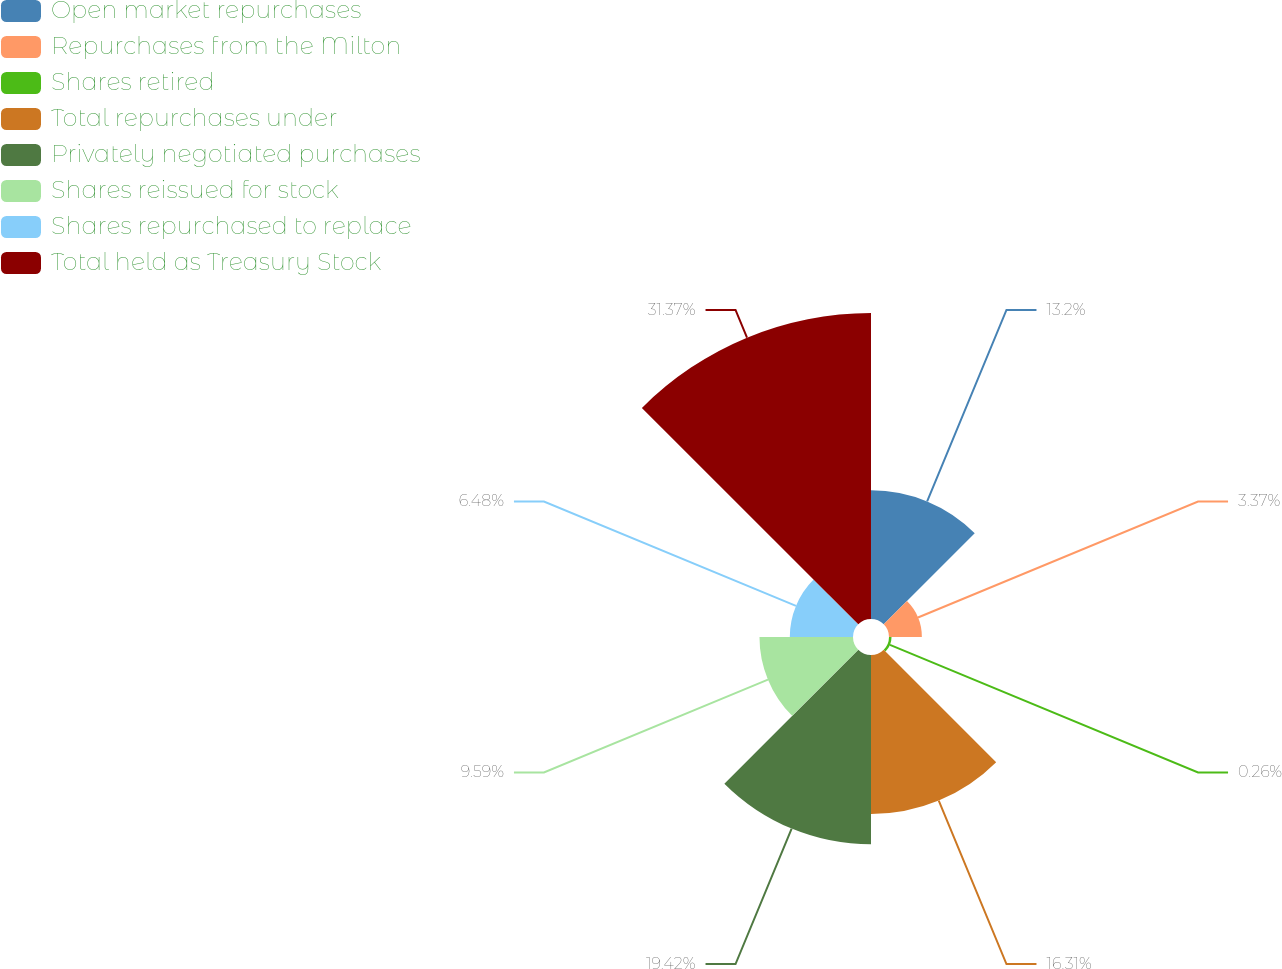Convert chart to OTSL. <chart><loc_0><loc_0><loc_500><loc_500><pie_chart><fcel>Open market repurchases<fcel>Repurchases from the Milton<fcel>Shares retired<fcel>Total repurchases under<fcel>Privately negotiated purchases<fcel>Shares reissued for stock<fcel>Shares repurchased to replace<fcel>Total held as Treasury Stock<nl><fcel>13.2%<fcel>3.37%<fcel>0.26%<fcel>16.31%<fcel>19.42%<fcel>9.59%<fcel>6.48%<fcel>31.38%<nl></chart> 